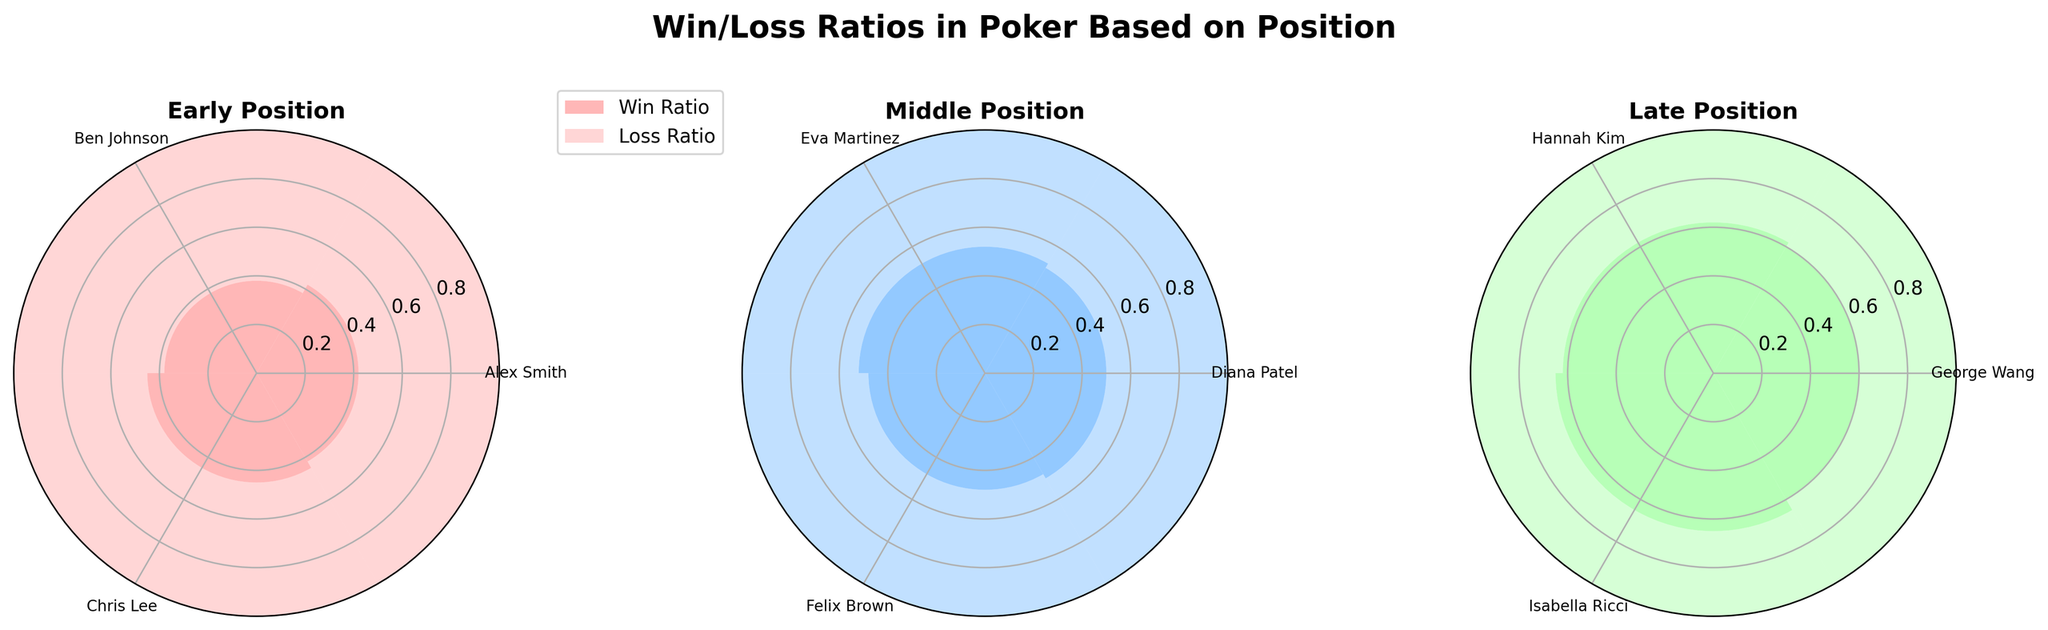What is the win ratio for Alex Smith in the early position? To find the win ratio for Alex Smith in the early position, locate his name on the corresponding subplot (Early Position) and refer to the height of the bar labeled as 'Win Ratio'. The win ratio for Alex Smith is 0.42.
Answer: 0.42 Which position has the highest average win ratio? To determine the highest average win ratio by position, calculate the average win ratio for each position. Early Position: (0.42 + 0.38 + 0.45) / 3 = 0.4167. Middle Position: (0.50 + 0.52 + 0.48) / 3 = 0.5. Late Position: (0.60 + 0.62 + 0.65) / 3 = 0.6233. The Late Position has the highest average win ratio.
Answer: Late Position Who has the highest win ratio in the middle position? To identify the player with the highest win ratio in the Middle Position subplot, compare the win ratios of Diana Patel, Eva Martinez, and Felix Brown. Eva Martinez has the highest win ratio of 0.52.
Answer: Eva Martinez How does the win ratio for George Wang in the Late Position compare to Chris Lee in the Early Position? Compare the win ratios of George Wang in the Late Position subplot (0.60) and Chris Lee in the Early Position subplot (0.45). George Wang has a higher win ratio compared to Chris Lee.
Answer: George Wang's win ratio is higher What is the combined loss ratio for all players in the late position? Sum the loss ratios of George Wang, Hannah Kim, and Isabella Ricci in the Late Position subplot. Combined loss ratio = 0.40 + 0.38 + 0.35 = 1.13.
Answer: 1.13 Which position has the lowest individual win ratio, and who is the player? Identify the win ratios for all players across the three subplots. The lowest individual win ratio is found in the Early Position, with Ben Johnson having a win ratio of 0.38.
Answer: Early Position, Ben Johnson How does the loss ratio for Diana Patel in the Middle Position compare to Ben Johnson in the Early Position? Compare Diana Patel’s loss ratio in the Middle Position subplot (0.50) to Ben Johnson’s loss ratio in the Early Position subplot (0.62). Ben Johnson has a higher loss ratio compared to Diana Patel.
Answer: Ben Johnson's loss ratio is higher 